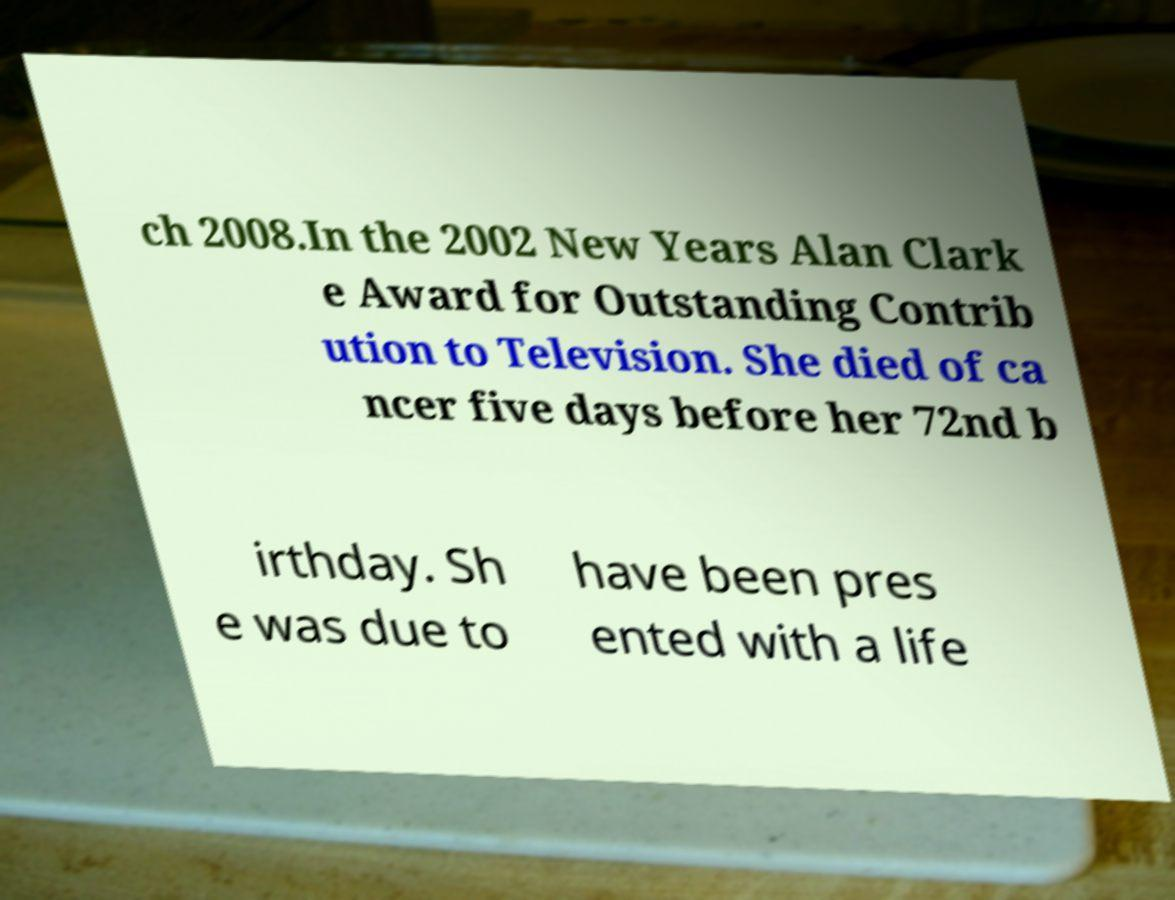Can you accurately transcribe the text from the provided image for me? ch 2008.In the 2002 New Years Alan Clark e Award for Outstanding Contrib ution to Television. She died of ca ncer five days before her 72nd b irthday. Sh e was due to have been pres ented with a life 